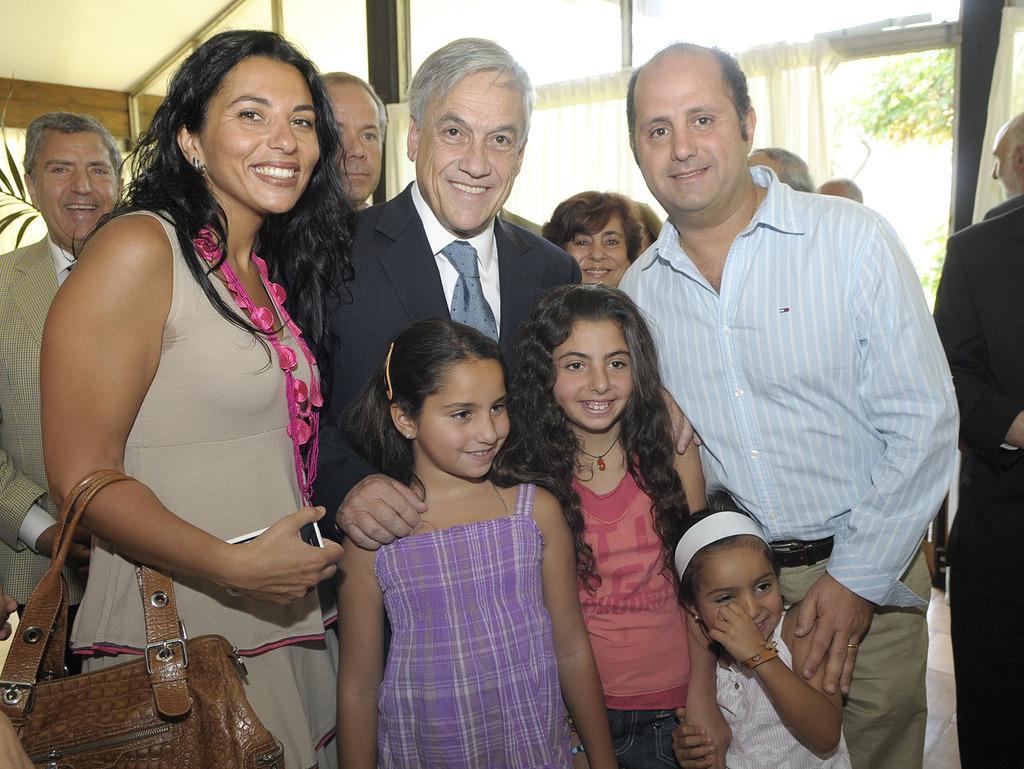How would you summarize this image in a sentence or two? In this image, we can see group of people are standing. And they are smiling. In the middle, we can see 3 girls are standing. The left side, women hold a bag and mobile on his hand. Background, we can see curtain, glass window, wooden and plant hire. Right side, we can see tree. 